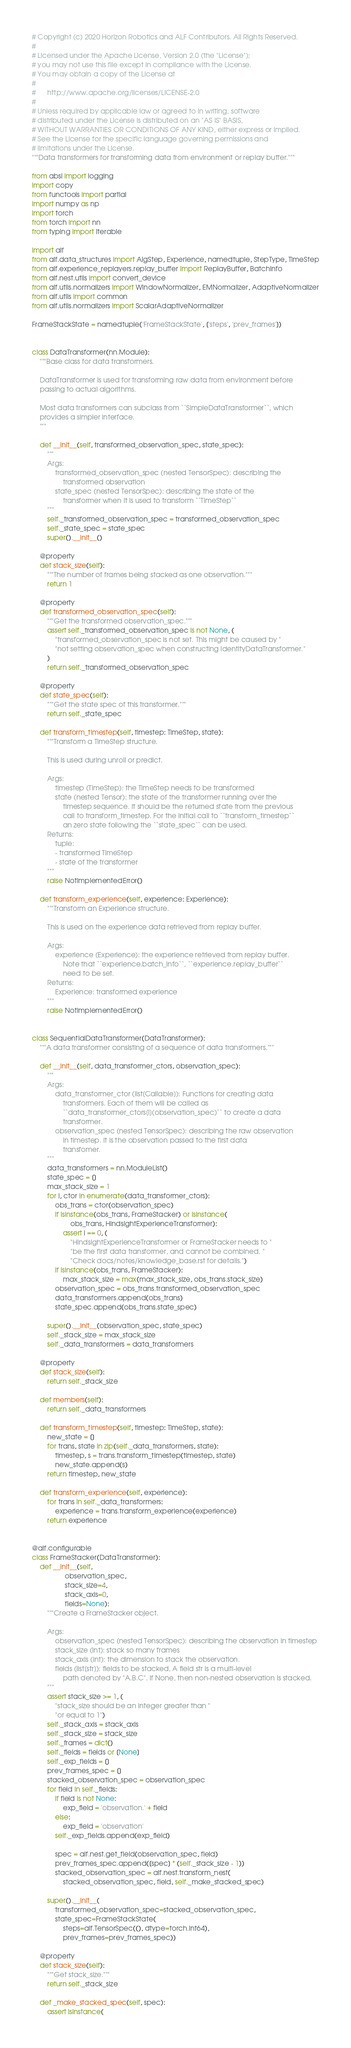Convert code to text. <code><loc_0><loc_0><loc_500><loc_500><_Python_># Copyright (c) 2020 Horizon Robotics and ALF Contributors. All Rights Reserved.
#
# Licensed under the Apache License, Version 2.0 (the "License");
# you may not use this file except in compliance with the License.
# You may obtain a copy of the License at
#
#      http://www.apache.org/licenses/LICENSE-2.0
#
# Unless required by applicable law or agreed to in writing, software
# distributed under the License is distributed on an "AS IS" BASIS,
# WITHOUT WARRANTIES OR CONDITIONS OF ANY KIND, either express or implied.
# See the License for the specific language governing permissions and
# limitations under the License.
"""Data transformers for transforming data from environment or replay buffer."""

from absl import logging
import copy
from functools import partial
import numpy as np
import torch
from torch import nn
from typing import Iterable

import alf
from alf.data_structures import AlgStep, Experience, namedtuple, StepType, TimeStep
from alf.experience_replayers.replay_buffer import ReplayBuffer, BatchInfo
from alf.nest.utils import convert_device
from alf.utils.normalizers import WindowNormalizer, EMNormalizer, AdaptiveNormalizer
from alf.utils import common
from alf.utils.normalizers import ScalarAdaptiveNormalizer

FrameStackState = namedtuple('FrameStackState', ['steps', 'prev_frames'])


class DataTransformer(nn.Module):
    """Base class for data transformers.

    DataTransformer is used for transforming raw data from environment before
    passing to actual algorithms.

    Most data transformers can subclass from ``SimpleDataTransformer``, which
    provides a simpler interface.
    """

    def __init__(self, transformed_observation_spec, state_spec):
        """
        Args:
            transformed_observation_spec (nested TensorSpec): describing the
                transformed observation
            state_spec (nested TensorSpec): describing the state of the
                transformer when it is used to transform ``TimeStep``
        """
        self._transformed_observation_spec = transformed_observation_spec
        self._state_spec = state_spec
        super().__init__()

    @property
    def stack_size(self):
        """The number of frames being stacked as one observation."""
        return 1

    @property
    def transformed_observation_spec(self):
        """Get the transformed observation_spec."""
        assert self._transformed_observation_spec is not None, (
            "transformed_observation_spec is not set. This might be caused by "
            "not setting observation_spec when constructing IdentityDataTransformer."
        )
        return self._transformed_observation_spec

    @property
    def state_spec(self):
        """Get the state spec of this transformer."""
        return self._state_spec

    def transform_timestep(self, timestep: TimeStep, state):
        """Transform a TimeStep structure.

        This is used during unroll or predict.

        Args:
            timestep (TimeStep): the TimeStep needs to be transformed
            state (nested Tensor): the state of the transformer running over the
                timestep sequence. It should be the returned state from the previous
                call to transform_timestep. For the initial call to ``transform_timestep``
                an zero state following the ``state_spec`` can be used.
        Returns:
            tuple:
            - transformed TimeStep
            - state of the transformer
        """
        raise NotImplementedError()

    def transform_experience(self, experience: Experience):
        """Transform an Experience structure.

        This is used on the experience data retrieved from replay buffer.

        Args:
            experience (Experience): the experience retrieved from replay buffer.
                Note that ``experience.batch_info``, ``experience.replay_buffer``
                need to be set.
        Returns:
            Experience: transformed experience
        """
        raise NotImplementedError()


class SequentialDataTransformer(DataTransformer):
    """A data transformer consisting of a sequence of data transformers."""

    def __init__(self, data_transformer_ctors, observation_spec):
        """
        Args:
            data_transformer_ctor (list[Callable]): Functions for creating data
                transformers. Each of them will be called as
                ``data_transformer_ctors[i](observation_spec)`` to create a data
                transformer.
            observation_spec (nested TensorSpec): describing the raw observation
                in timestep. It is the observation passed to the first data
                transfomer.
        """
        data_transformers = nn.ModuleList()
        state_spec = []
        max_stack_size = 1
        for i, ctor in enumerate(data_transformer_ctors):
            obs_trans = ctor(observation_spec)
            if isinstance(obs_trans, FrameStacker) or isinstance(
                    obs_trans, HindsightExperienceTransformer):
                assert i == 0, (
                    "HindsightExperienceTransformer or FrameStacker needs to "
                    "be the first data transformer, and cannot be combined. "
                    "Check docs/notes/knowledge_base.rst for details.")
            if isinstance(obs_trans, FrameStacker):
                max_stack_size = max(max_stack_size, obs_trans.stack_size)
            observation_spec = obs_trans.transformed_observation_spec
            data_transformers.append(obs_trans)
            state_spec.append(obs_trans.state_spec)

        super().__init__(observation_spec, state_spec)
        self._stack_size = max_stack_size
        self._data_transformers = data_transformers

    @property
    def stack_size(self):
        return self._stack_size

    def members(self):
        return self._data_transformers

    def transform_timestep(self, timestep: TimeStep, state):
        new_state = []
        for trans, state in zip(self._data_transformers, state):
            timestep, s = trans.transform_timestep(timestep, state)
            new_state.append(s)
        return timestep, new_state

    def transform_experience(self, experience):
        for trans in self._data_transformers:
            experience = trans.transform_experience(experience)
        return experience


@alf.configurable
class FrameStacker(DataTransformer):
    def __init__(self,
                 observation_spec,
                 stack_size=4,
                 stack_axis=0,
                 fields=None):
        """Create a FrameStacker object.

        Args:
            observation_spec (nested TensorSpec): describing the observation in timestep
            stack_size (int): stack so many frames
            stack_axis (int): the dimension to stack the observation.
            fields (list[str]): fields to be stacked, A field str is a multi-level
                path denoted by "A.B.C". If None, then non-nested observation is stacked.
        """
        assert stack_size >= 1, (
            "stack_size should be an integer greater than "
            "or equal to 1")
        self._stack_axis = stack_axis
        self._stack_size = stack_size
        self._frames = dict()
        self._fields = fields or [None]
        self._exp_fields = []
        prev_frames_spec = []
        stacked_observation_spec = observation_spec
        for field in self._fields:
            if field is not None:
                exp_field = 'observation.' + field
            else:
                exp_field = 'observation'
            self._exp_fields.append(exp_field)

            spec = alf.nest.get_field(observation_spec, field)
            prev_frames_spec.append([spec] * (self._stack_size - 1))
            stacked_observation_spec = alf.nest.transform_nest(
                stacked_observation_spec, field, self._make_stacked_spec)

        super().__init__(
            transformed_observation_spec=stacked_observation_spec,
            state_spec=FrameStackState(
                steps=alf.TensorSpec((), dtype=torch.int64),
                prev_frames=prev_frames_spec))

    @property
    def stack_size(self):
        """Get stack_size."""
        return self._stack_size

    def _make_stacked_spec(self, spec):
        assert isinstance(</code> 